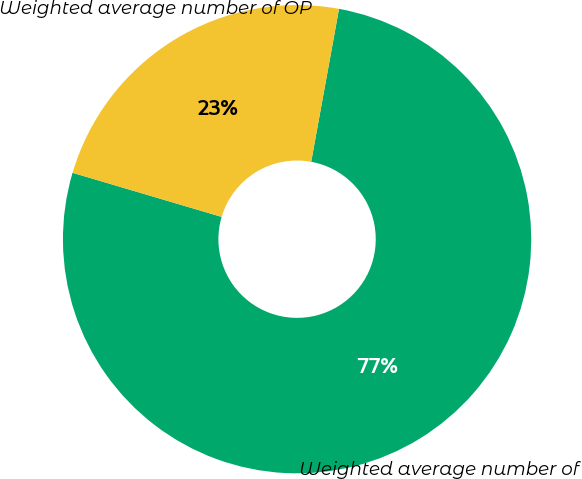Convert chart. <chart><loc_0><loc_0><loc_500><loc_500><pie_chart><fcel>Weighted average number of<fcel>Weighted average number of OP<nl><fcel>76.71%<fcel>23.29%<nl></chart> 